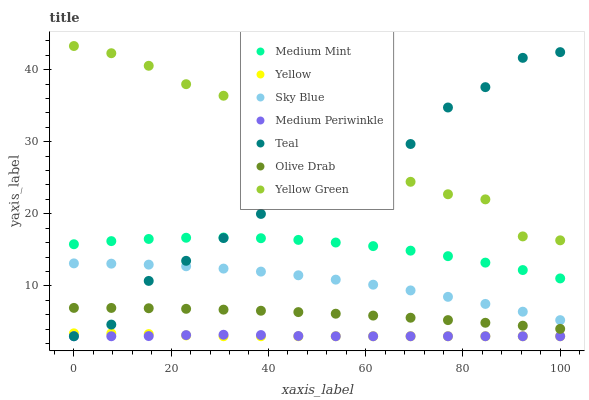Does Medium Periwinkle have the minimum area under the curve?
Answer yes or no. Yes. Does Yellow Green have the maximum area under the curve?
Answer yes or no. Yes. Does Yellow Green have the minimum area under the curve?
Answer yes or no. No. Does Medium Periwinkle have the maximum area under the curve?
Answer yes or no. No. Is Yellow the smoothest?
Answer yes or no. Yes. Is Teal the roughest?
Answer yes or no. Yes. Is Yellow Green the smoothest?
Answer yes or no. No. Is Yellow Green the roughest?
Answer yes or no. No. Does Medium Periwinkle have the lowest value?
Answer yes or no. Yes. Does Yellow Green have the lowest value?
Answer yes or no. No. Does Yellow Green have the highest value?
Answer yes or no. Yes. Does Medium Periwinkle have the highest value?
Answer yes or no. No. Is Olive Drab less than Yellow Green?
Answer yes or no. Yes. Is Olive Drab greater than Yellow?
Answer yes or no. Yes. Does Medium Periwinkle intersect Teal?
Answer yes or no. Yes. Is Medium Periwinkle less than Teal?
Answer yes or no. No. Is Medium Periwinkle greater than Teal?
Answer yes or no. No. Does Olive Drab intersect Yellow Green?
Answer yes or no. No. 